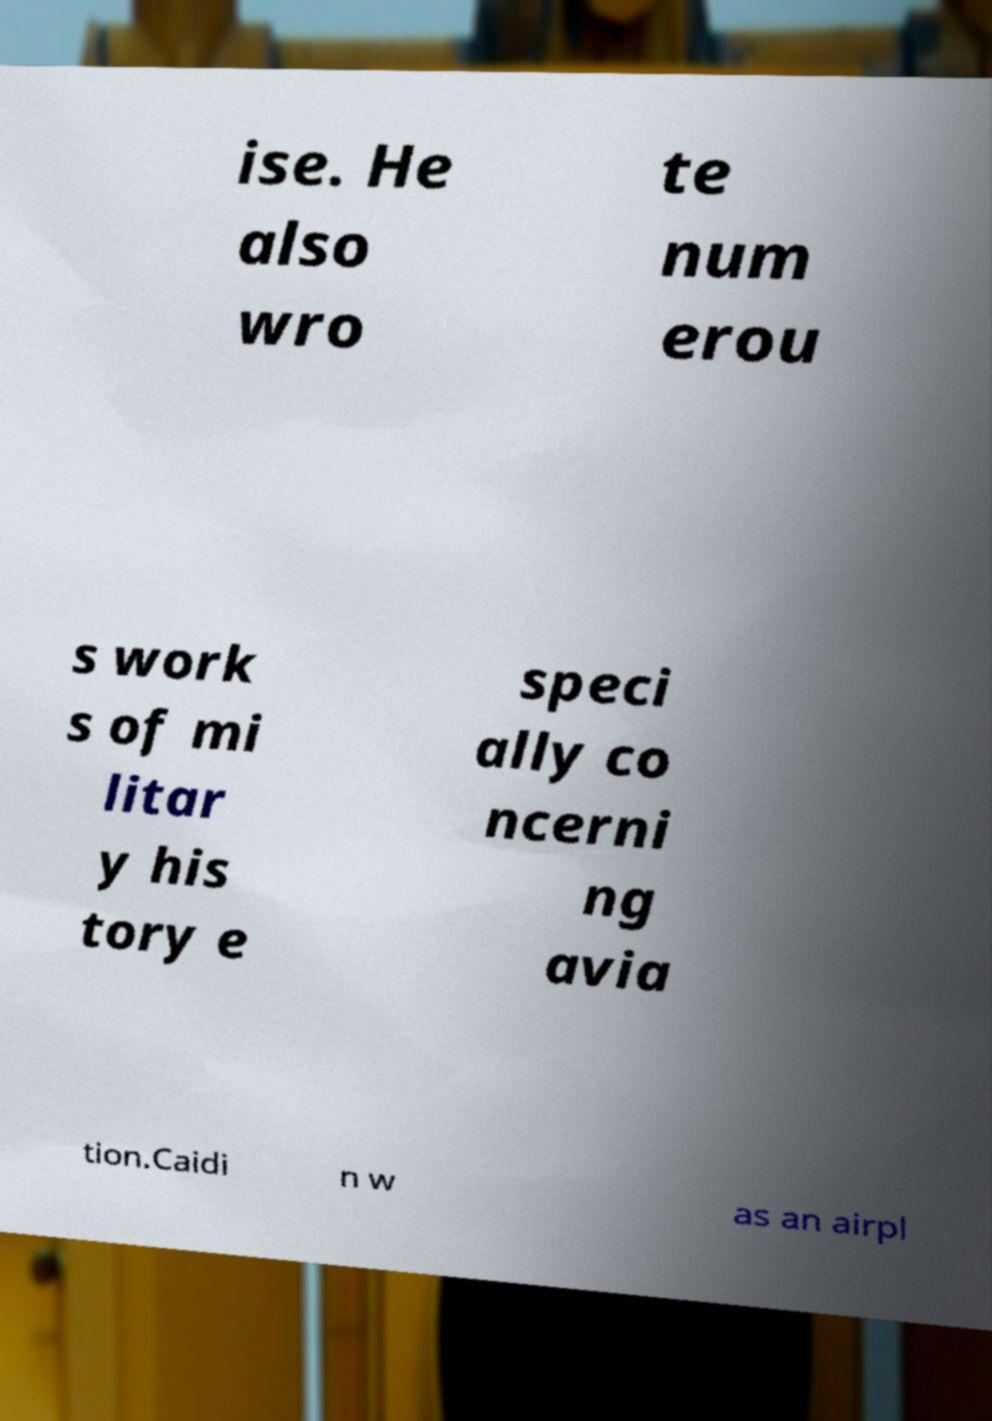There's text embedded in this image that I need extracted. Can you transcribe it verbatim? ise. He also wro te num erou s work s of mi litar y his tory e speci ally co ncerni ng avia tion.Caidi n w as an airpl 